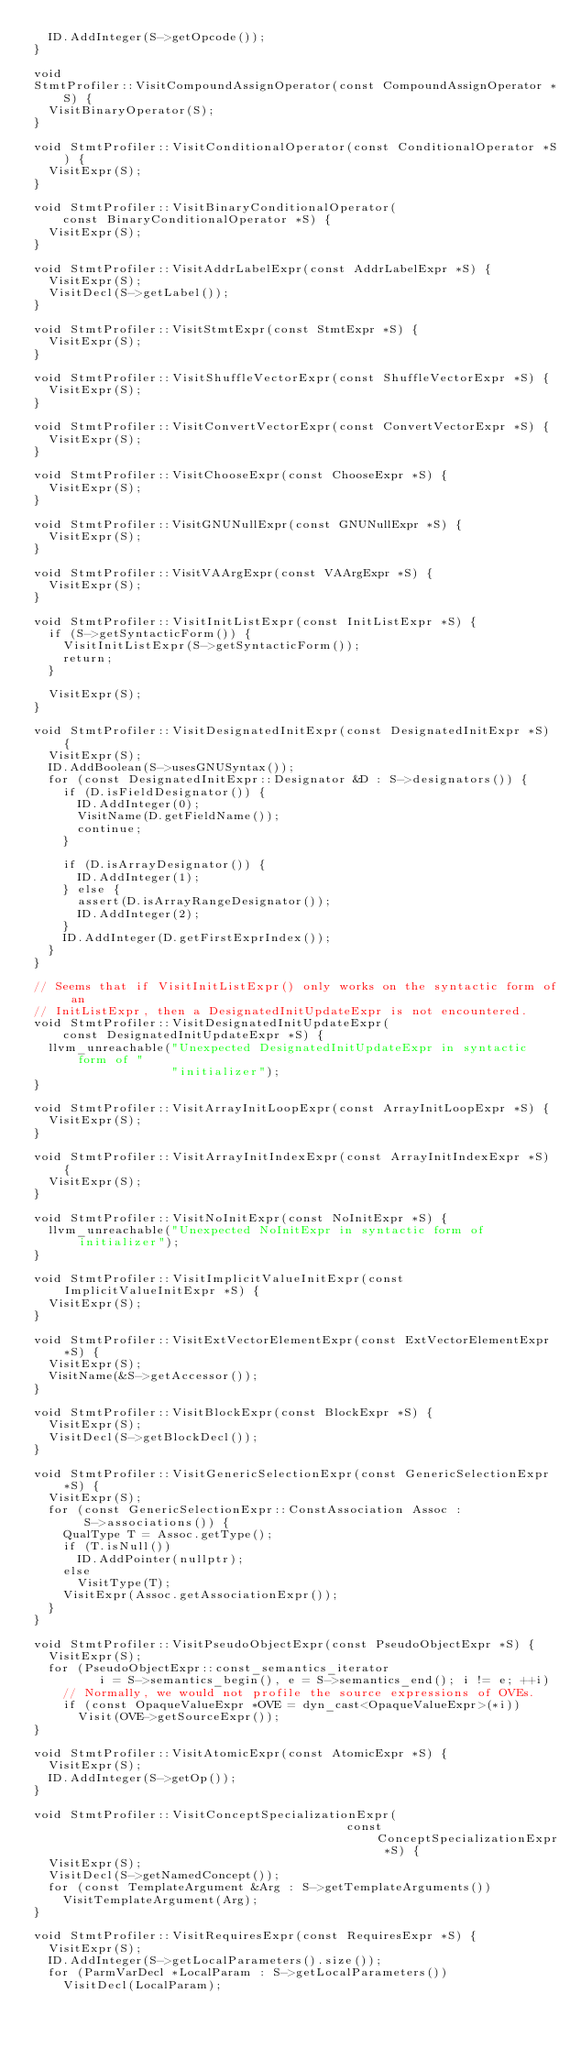<code> <loc_0><loc_0><loc_500><loc_500><_C++_>  ID.AddInteger(S->getOpcode());
}

void
StmtProfiler::VisitCompoundAssignOperator(const CompoundAssignOperator *S) {
  VisitBinaryOperator(S);
}

void StmtProfiler::VisitConditionalOperator(const ConditionalOperator *S) {
  VisitExpr(S);
}

void StmtProfiler::VisitBinaryConditionalOperator(
    const BinaryConditionalOperator *S) {
  VisitExpr(S);
}

void StmtProfiler::VisitAddrLabelExpr(const AddrLabelExpr *S) {
  VisitExpr(S);
  VisitDecl(S->getLabel());
}

void StmtProfiler::VisitStmtExpr(const StmtExpr *S) {
  VisitExpr(S);
}

void StmtProfiler::VisitShuffleVectorExpr(const ShuffleVectorExpr *S) {
  VisitExpr(S);
}

void StmtProfiler::VisitConvertVectorExpr(const ConvertVectorExpr *S) {
  VisitExpr(S);
}

void StmtProfiler::VisitChooseExpr(const ChooseExpr *S) {
  VisitExpr(S);
}

void StmtProfiler::VisitGNUNullExpr(const GNUNullExpr *S) {
  VisitExpr(S);
}

void StmtProfiler::VisitVAArgExpr(const VAArgExpr *S) {
  VisitExpr(S);
}

void StmtProfiler::VisitInitListExpr(const InitListExpr *S) {
  if (S->getSyntacticForm()) {
    VisitInitListExpr(S->getSyntacticForm());
    return;
  }

  VisitExpr(S);
}

void StmtProfiler::VisitDesignatedInitExpr(const DesignatedInitExpr *S) {
  VisitExpr(S);
  ID.AddBoolean(S->usesGNUSyntax());
  for (const DesignatedInitExpr::Designator &D : S->designators()) {
    if (D.isFieldDesignator()) {
      ID.AddInteger(0);
      VisitName(D.getFieldName());
      continue;
    }

    if (D.isArrayDesignator()) {
      ID.AddInteger(1);
    } else {
      assert(D.isArrayRangeDesignator());
      ID.AddInteger(2);
    }
    ID.AddInteger(D.getFirstExprIndex());
  }
}

// Seems that if VisitInitListExpr() only works on the syntactic form of an
// InitListExpr, then a DesignatedInitUpdateExpr is not encountered.
void StmtProfiler::VisitDesignatedInitUpdateExpr(
    const DesignatedInitUpdateExpr *S) {
  llvm_unreachable("Unexpected DesignatedInitUpdateExpr in syntactic form of "
                   "initializer");
}

void StmtProfiler::VisitArrayInitLoopExpr(const ArrayInitLoopExpr *S) {
  VisitExpr(S);
}

void StmtProfiler::VisitArrayInitIndexExpr(const ArrayInitIndexExpr *S) {
  VisitExpr(S);
}

void StmtProfiler::VisitNoInitExpr(const NoInitExpr *S) {
  llvm_unreachable("Unexpected NoInitExpr in syntactic form of initializer");
}

void StmtProfiler::VisitImplicitValueInitExpr(const ImplicitValueInitExpr *S) {
  VisitExpr(S);
}

void StmtProfiler::VisitExtVectorElementExpr(const ExtVectorElementExpr *S) {
  VisitExpr(S);
  VisitName(&S->getAccessor());
}

void StmtProfiler::VisitBlockExpr(const BlockExpr *S) {
  VisitExpr(S);
  VisitDecl(S->getBlockDecl());
}

void StmtProfiler::VisitGenericSelectionExpr(const GenericSelectionExpr *S) {
  VisitExpr(S);
  for (const GenericSelectionExpr::ConstAssociation Assoc :
       S->associations()) {
    QualType T = Assoc.getType();
    if (T.isNull())
      ID.AddPointer(nullptr);
    else
      VisitType(T);
    VisitExpr(Assoc.getAssociationExpr());
  }
}

void StmtProfiler::VisitPseudoObjectExpr(const PseudoObjectExpr *S) {
  VisitExpr(S);
  for (PseudoObjectExpr::const_semantics_iterator
         i = S->semantics_begin(), e = S->semantics_end(); i != e; ++i)
    // Normally, we would not profile the source expressions of OVEs.
    if (const OpaqueValueExpr *OVE = dyn_cast<OpaqueValueExpr>(*i))
      Visit(OVE->getSourceExpr());
}

void StmtProfiler::VisitAtomicExpr(const AtomicExpr *S) {
  VisitExpr(S);
  ID.AddInteger(S->getOp());
}

void StmtProfiler::VisitConceptSpecializationExpr(
                                           const ConceptSpecializationExpr *S) {
  VisitExpr(S);
  VisitDecl(S->getNamedConcept());
  for (const TemplateArgument &Arg : S->getTemplateArguments())
    VisitTemplateArgument(Arg);
}

void StmtProfiler::VisitRequiresExpr(const RequiresExpr *S) {
  VisitExpr(S);
  ID.AddInteger(S->getLocalParameters().size());
  for (ParmVarDecl *LocalParam : S->getLocalParameters())
    VisitDecl(LocalParam);</code> 